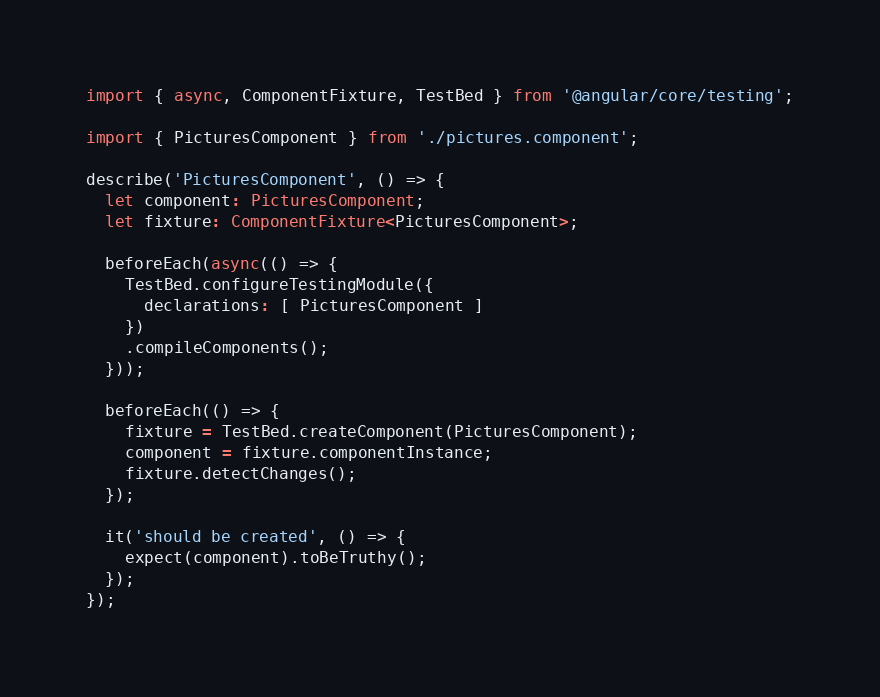<code> <loc_0><loc_0><loc_500><loc_500><_TypeScript_>import { async, ComponentFixture, TestBed } from '@angular/core/testing';

import { PicturesComponent } from './pictures.component';

describe('PicturesComponent', () => {
  let component: PicturesComponent;
  let fixture: ComponentFixture<PicturesComponent>;

  beforeEach(async(() => {
    TestBed.configureTestingModule({
      declarations: [ PicturesComponent ]
    })
    .compileComponents();
  }));

  beforeEach(() => {
    fixture = TestBed.createComponent(PicturesComponent);
    component = fixture.componentInstance;
    fixture.detectChanges();
  });

  it('should be created', () => {
    expect(component).toBeTruthy();
  });
});
</code> 